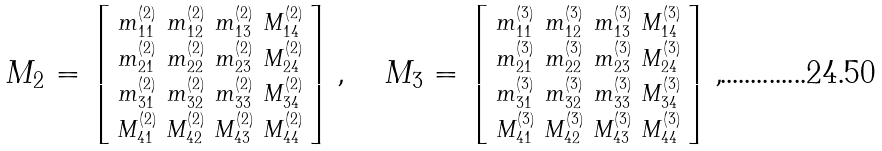Convert formula to latex. <formula><loc_0><loc_0><loc_500><loc_500>M _ { 2 } = \left [ \begin{smallmatrix} m ^ { ( 2 ) } _ { 1 1 } & m ^ { ( 2 ) } _ { 1 2 } & m ^ { ( 2 ) } _ { 1 3 } & M ^ { ( 2 ) } _ { 1 4 } \\ m ^ { ( 2 ) } _ { 2 1 } & m ^ { ( 2 ) } _ { 2 2 } & m ^ { ( 2 ) } _ { 2 3 } & M ^ { ( 2 ) } _ { 2 4 } \\ m ^ { ( 2 ) } _ { 3 1 } & m ^ { ( 2 ) } _ { 3 2 } & m ^ { ( 2 ) } _ { 3 3 } & M ^ { ( 2 ) } _ { 3 4 } \\ M ^ { ( 2 ) } _ { 4 1 } & M ^ { ( 2 ) } _ { 4 2 } & M ^ { ( 2 ) } _ { 4 3 } & M ^ { ( 2 ) } _ { 4 4 } \end{smallmatrix} \right ] , \quad M _ { 3 } = \left [ \begin{smallmatrix} m ^ { ( 3 ) } _ { 1 1 } & m ^ { ( 3 ) } _ { 1 2 } & m ^ { ( 3 ) } _ { 1 3 } & M ^ { ( 3 ) } _ { 1 4 } \\ m ^ { ( 3 ) } _ { 2 1 } & m ^ { ( 3 ) } _ { 2 2 } & m ^ { ( 3 ) } _ { 2 3 } & M ^ { ( 3 ) } _ { 2 4 } \\ m ^ { ( 3 ) } _ { 3 1 } & m ^ { ( 3 ) } _ { 3 2 } & m ^ { ( 3 ) } _ { 3 3 } & M ^ { ( 3 ) } _ { 3 4 } \\ M ^ { ( 3 ) } _ { 4 1 } & M ^ { ( 3 ) } _ { 4 2 } & M ^ { ( 3 ) } _ { 4 3 } & M ^ { ( 3 ) } _ { 4 4 } \end{smallmatrix} \right ] ,</formula> 